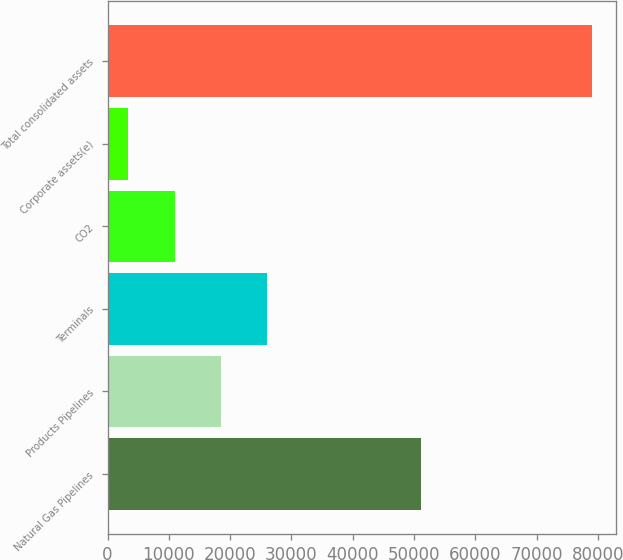Convert chart. <chart><loc_0><loc_0><loc_500><loc_500><bar_chart><fcel>Natural Gas Pipelines<fcel>Products Pipelines<fcel>Terminals<fcel>CO2<fcel>Corporate assets(e)<fcel>Total consolidated assets<nl><fcel>51173<fcel>18516.6<fcel>26083.9<fcel>10949.3<fcel>3382<fcel>79055<nl></chart> 